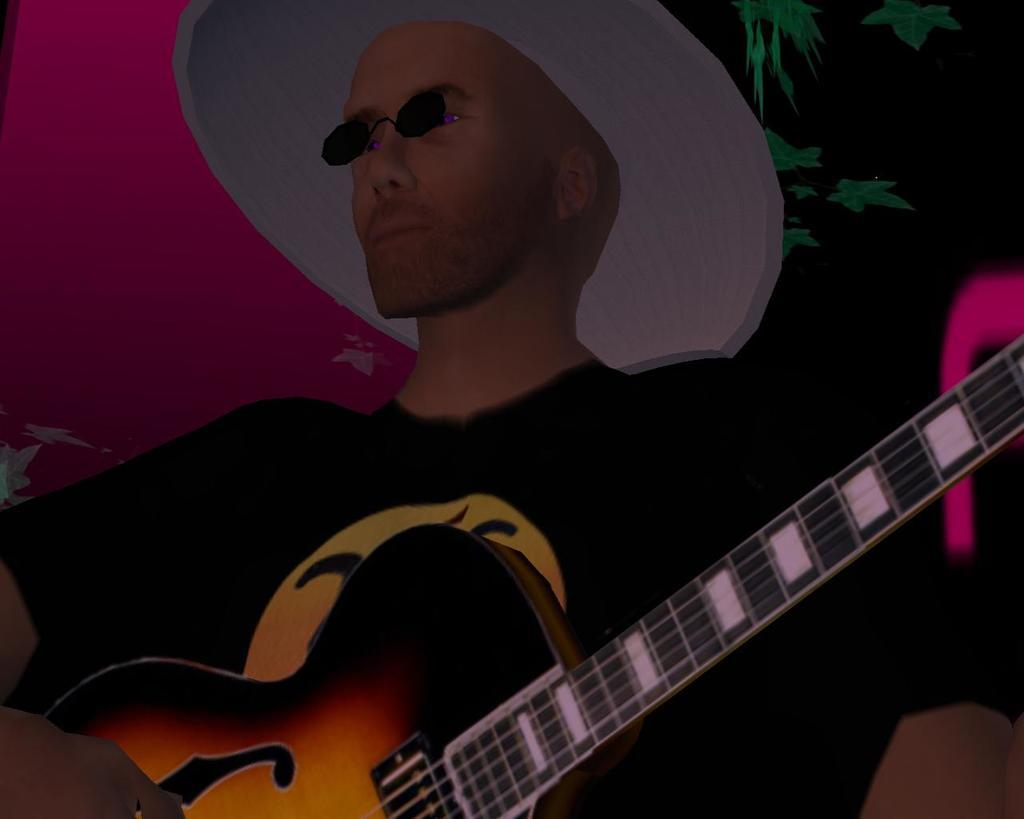What type of image is being depicted? The image is an animated picture. Can you describe the person in the image? There is a person in the image. What accessory is the person wearing? The person is wearing a hat. What object is the person holding in the image? The person is holding a guitar. What type of food is the person trading in the image? There is no indication of food or trading in the image; it features a person wearing a hat and holding a guitar. 